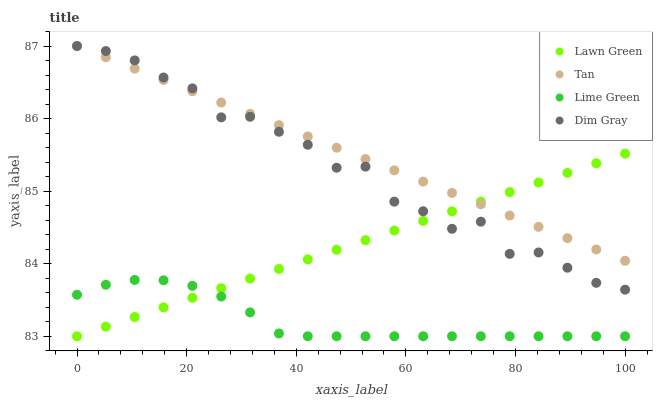Does Lime Green have the minimum area under the curve?
Answer yes or no. Yes. Does Tan have the maximum area under the curve?
Answer yes or no. Yes. Does Dim Gray have the minimum area under the curve?
Answer yes or no. No. Does Dim Gray have the maximum area under the curve?
Answer yes or no. No. Is Tan the smoothest?
Answer yes or no. Yes. Is Dim Gray the roughest?
Answer yes or no. Yes. Is Dim Gray the smoothest?
Answer yes or no. No. Is Tan the roughest?
Answer yes or no. No. Does Lawn Green have the lowest value?
Answer yes or no. Yes. Does Dim Gray have the lowest value?
Answer yes or no. No. Does Dim Gray have the highest value?
Answer yes or no. Yes. Does Lime Green have the highest value?
Answer yes or no. No. Is Lime Green less than Dim Gray?
Answer yes or no. Yes. Is Dim Gray greater than Lime Green?
Answer yes or no. Yes. Does Tan intersect Lawn Green?
Answer yes or no. Yes. Is Tan less than Lawn Green?
Answer yes or no. No. Is Tan greater than Lawn Green?
Answer yes or no. No. Does Lime Green intersect Dim Gray?
Answer yes or no. No. 